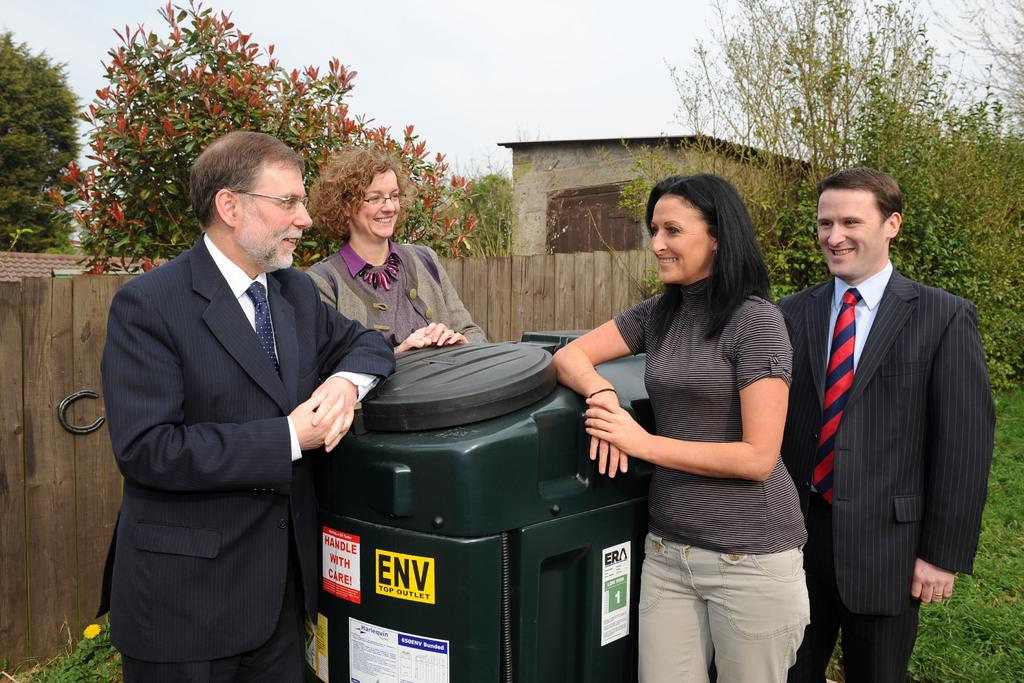<image>
Provide a brief description of the given image. Four adults sit around a container with a sticker ENV TOP OUTLET 